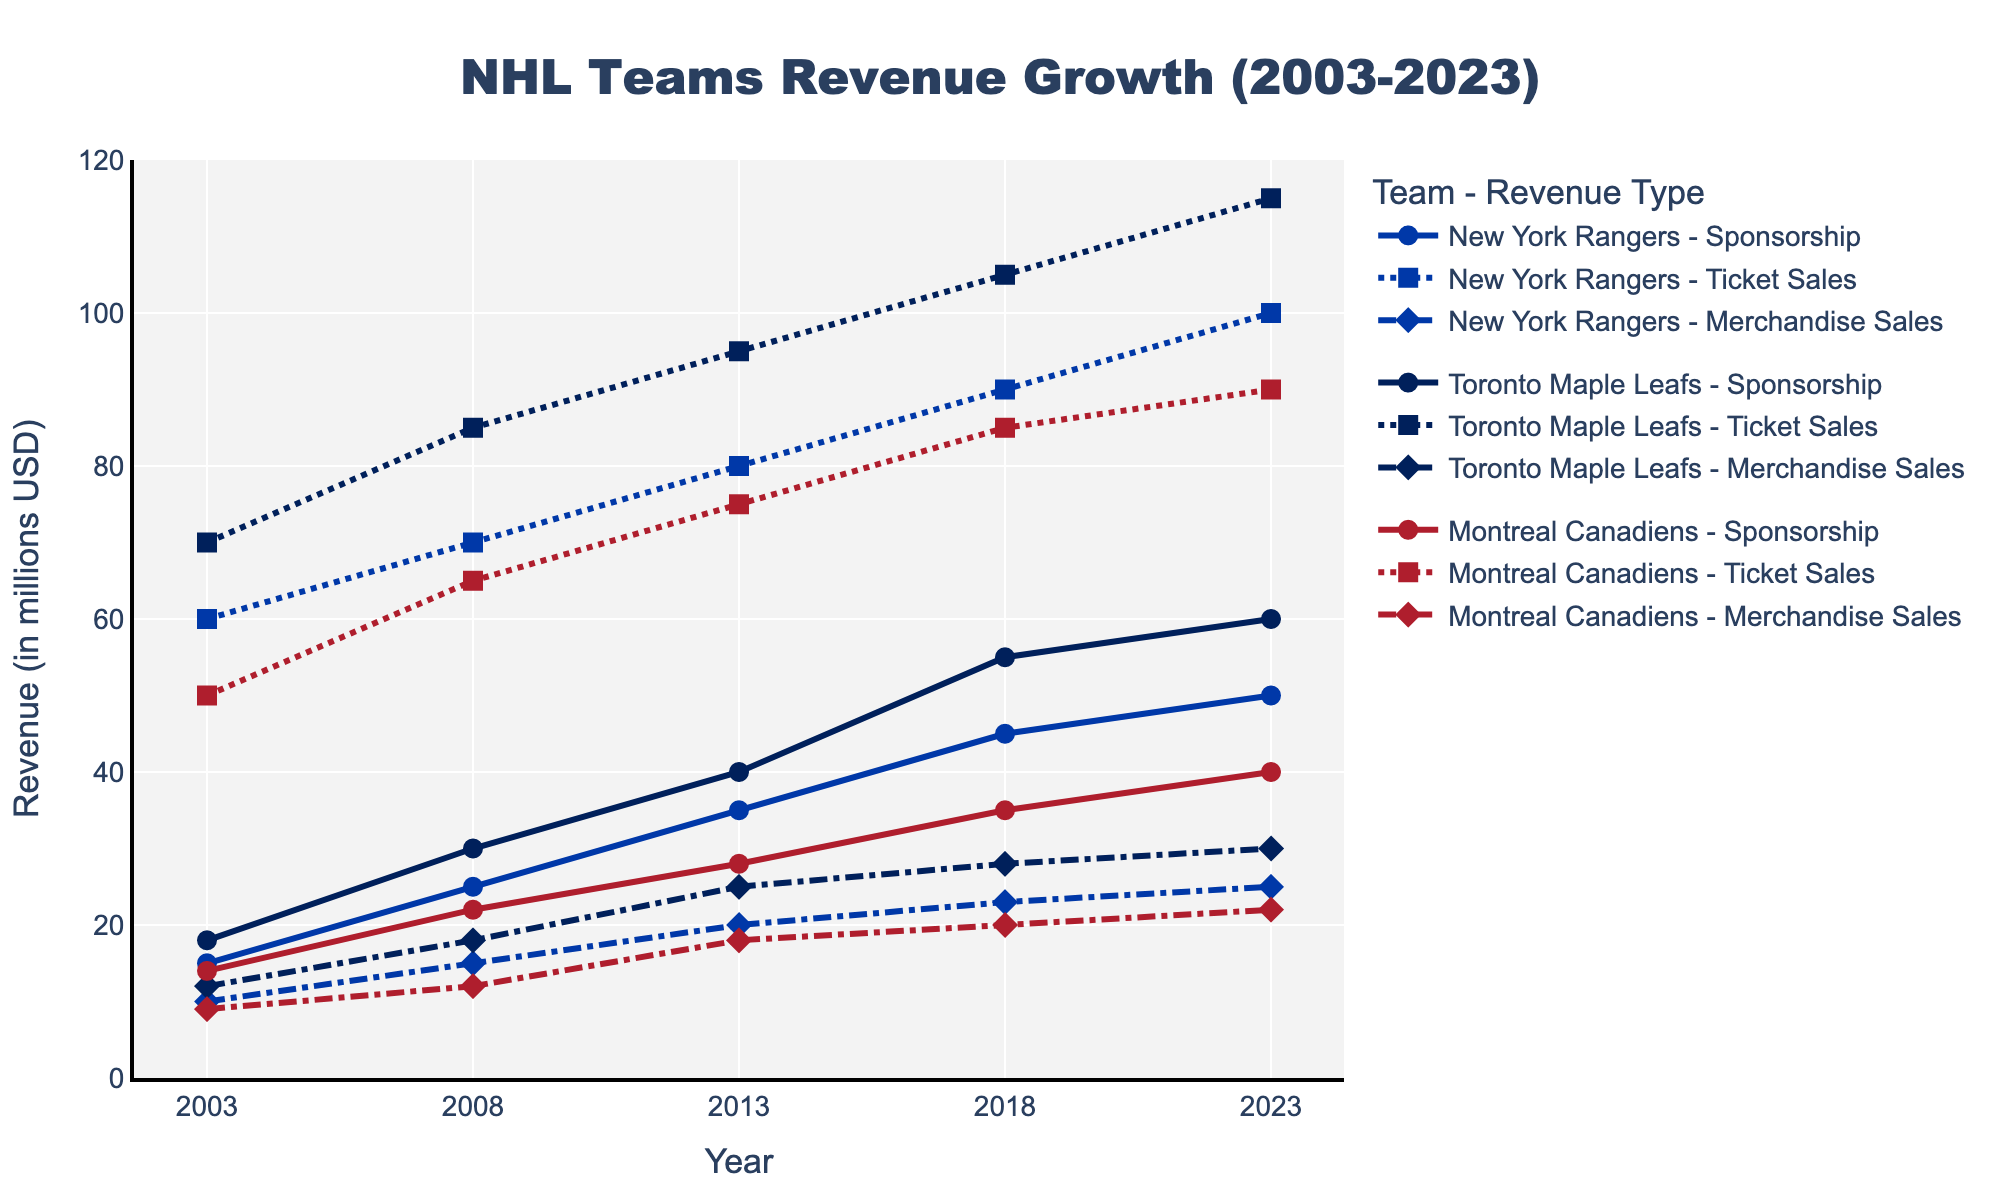What is the title of the figure? The title of the figure can be found at the top center, which is usually provided to give context about the data being visualized.
Answer: NHL Teams Revenue Growth (2003-2023) Which team had the highest sponsorship revenue in 2023? By looking at the sponsorship revenue lines on the time series plot and focusing on the year 2023, you can identify which team reached the highest point for sponsorship revenue.
Answer: Toronto Maple Leafs What was the ticket sales revenue for the Montreal Canadiens in 2008? To find this, locate the Montreal Canadiens' ticket sales revenue line, which is a dotted line, and note the value corresponding to the year 2008.
Answer: 65 million USD How much did the New York Rangers' merchandise sales revenue grow from 2003 to 2023? Locate the values for the New York Rangers' merchandise sales revenue in 2003 and 2023, then calculate the difference between these two values. The merchandise sales revenue in 2003 was 10 million USD and in 2023, it was 25 million USD, so the growth is calculated as 25 - 10 = 15.
Answer: 15 million USD Between 2003 and 2023, which team had the most consistent increase in ticket sales revenue? Observe the lines corresponding to ticket sales for all teams and analyze the trend from 2003 to 2023. The team with the smoothest upward trend without significant dips has the most consistent increase.
Answer: Toronto Maple Leafs During which time period did the Toronto Maple Leafs see the largest increase in merchandise sales revenue? Look at the Toronto Maple Leafs' merchandise sales revenue line and identify the periods between the given years. Calculate the increase for each period and determine the largest one. The increase from 2013 to 2018 is 28 - 25 = 3 million USD, and from 2008 to 2013 is 25 - 18 = 7 million USD, and from 2003 to 2008 is 18 - 12 = 6 million USD. The largest increase happened from 2008 to 2013.
Answer: 2008 to 2013 How many teams are represented in the figure? By referencing the legend or by counting the distinct revenue lines color-coded for each team, you can determine the number of teams depicted.
Answer: 3 Which team had the least sponsorship revenue in 2013? Examine the sponsorship revenue lines for the year 2013 and identify the lowest value among the teams.
Answer: Montreal Canadiens By how much did the ticket sales revenue for the Montreal Canadiens change from 2013 to 2023? Check the value for Montreal Canadiens' ticket sales revenue in 2013 and in 2023, then calculate the difference. The ticket sales revenue in 2013 was 75 million USD, and in 2023, it was 90 million USD, so the change is 90 - 75 = 15.
Answer: 15 million USD 